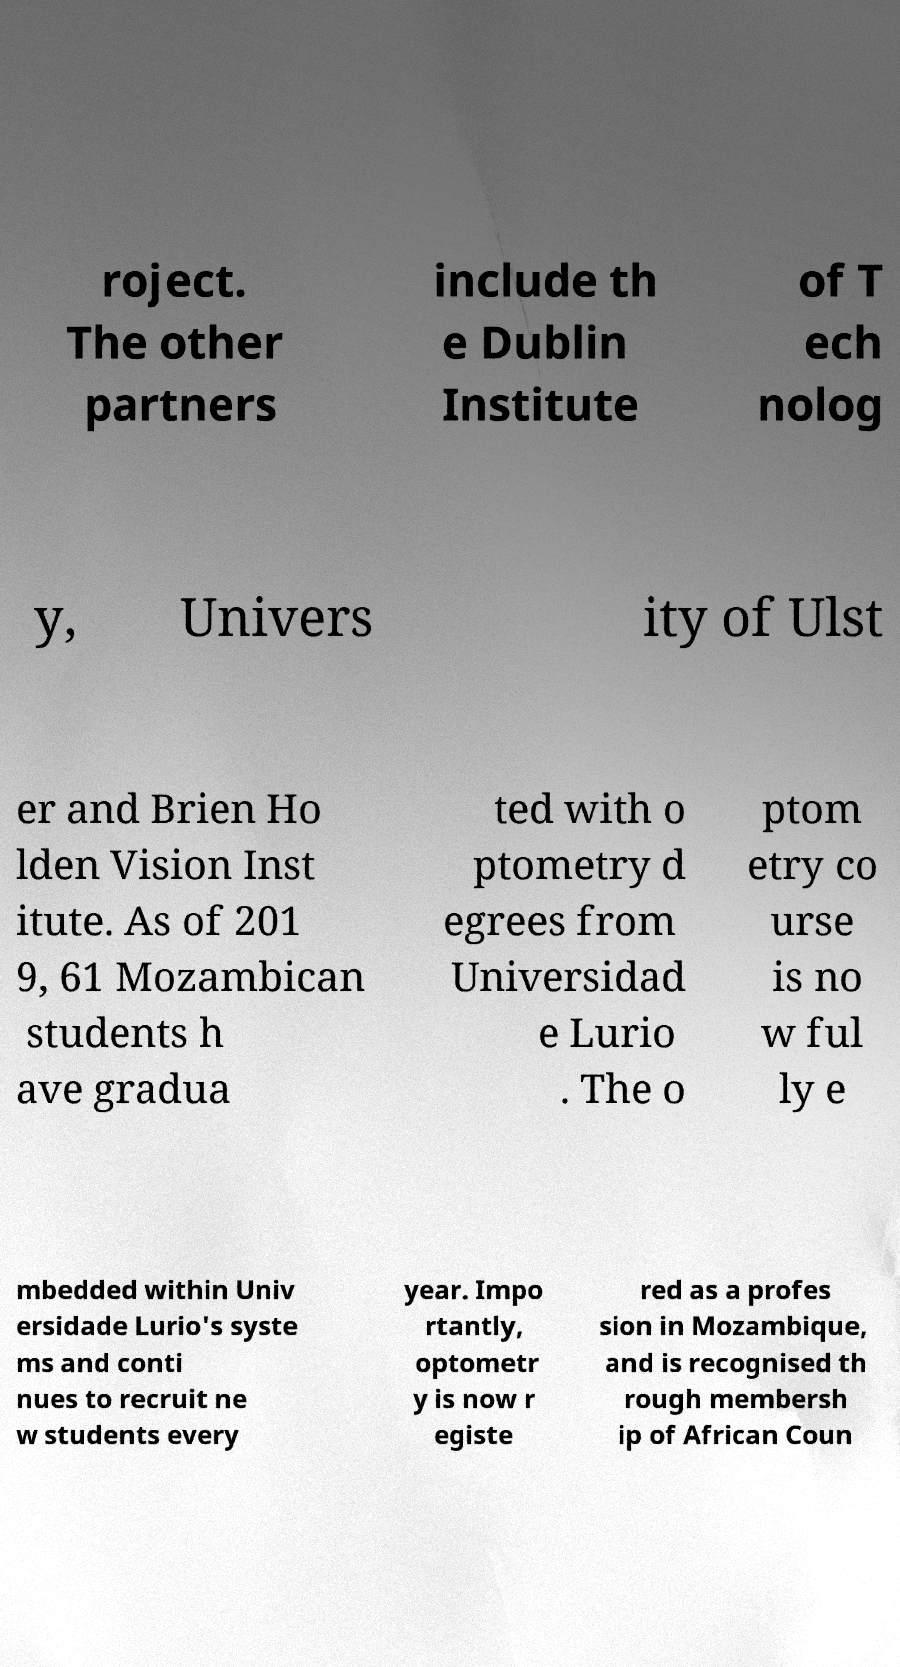For documentation purposes, I need the text within this image transcribed. Could you provide that? roject. The other partners include th e Dublin Institute of T ech nolog y, Univers ity of Ulst er and Brien Ho lden Vision Inst itute. As of 201 9, 61 Mozambican students h ave gradua ted with o ptometry d egrees from Universidad e Lurio . The o ptom etry co urse is no w ful ly e mbedded within Univ ersidade Lurio's syste ms and conti nues to recruit ne w students every year. Impo rtantly, optometr y is now r egiste red as a profes sion in Mozambique, and is recognised th rough membersh ip of African Coun 